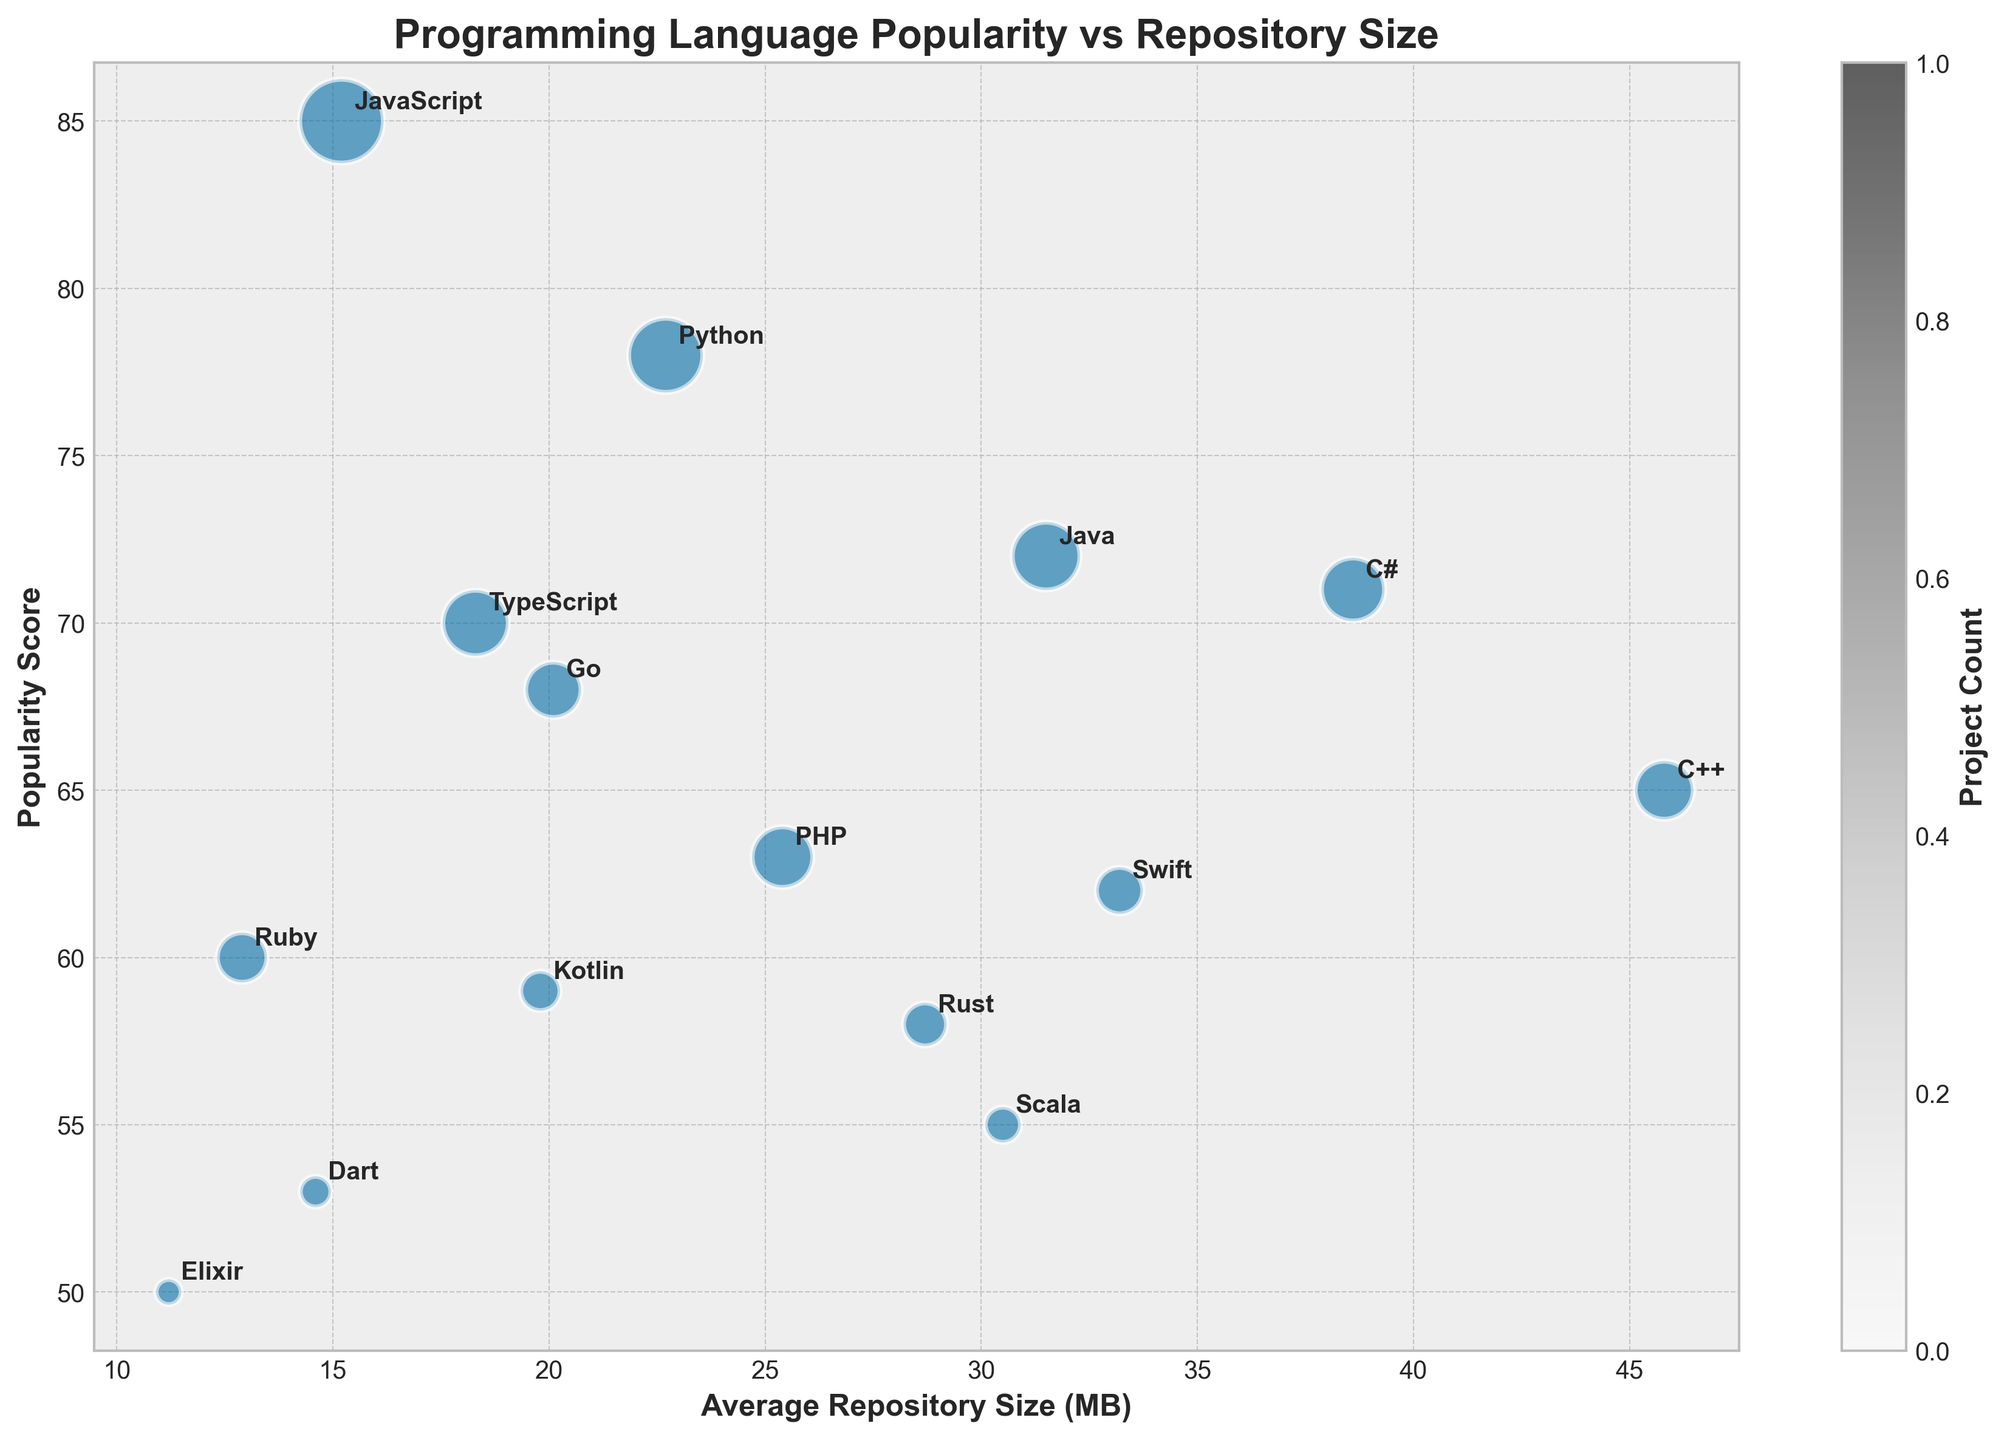Who has the highest popularity score? Identify the bubble representing the language with the highest position on the vertical 'Popularity Score' axis. Rust's bubble is the highest on this axis.
Answer: Rust Which language has the smallest average repository size? Identify the smallest bubble positioned most to the left on the horizontal 'Average Repository Size' axis. Elixir's bubble is the furthest to the left.
Answer: Elixir How many languages have an average repository size above 30MB? Count all bubbles positioned to the right of the '30MB' mark on the 'Average Repository Size' axis. Java, C++, C#, Swift, Scala, and Rust are to the right of the '30MB' mark.
Answer: 6 Which language has the largest bubble representing the project count? The size of bubbles represents the project count. Identify the biggest bubble visually. JavaScript's bubble is the largest.
Answer: JavaScript What is the relationship between average repository size and popularity score for Python compared to JavaScript? Look where the bubbles for Python and JavaScript are positioned. Python has a higher average repository size but a lower popularity score than JavaScript.
Answer: Higher average size, lower popularity Which language has a higher popularity score, Go or TypeScript? Compare the vertical positions of Go and TypeScript. Go's bubble is positioned higher on the 'Popularity Score' axis.
Answer: Go Which language has a similar average repository size but a higher popularity score compared to Ruby? Find the bubble with a similar horizontal position to Ruby but a higher vertical position. JavaScript is very close in average size but higher on the popularity score axis.
Answer: JavaScript What is the programming language with the second lowest project count as represented by bubble size? Sort the bubble sizes by eye and pick the second smallest. Elixir has the smallest bubble, and Dart is the one right after Elixir.
Answer: Dart Between Swift and Kotlin, which has a larger average repository size? Compare the horizontal positions of Swift and Kotlin. Swift is further to the right than Kotlin.
Answer: Swift 